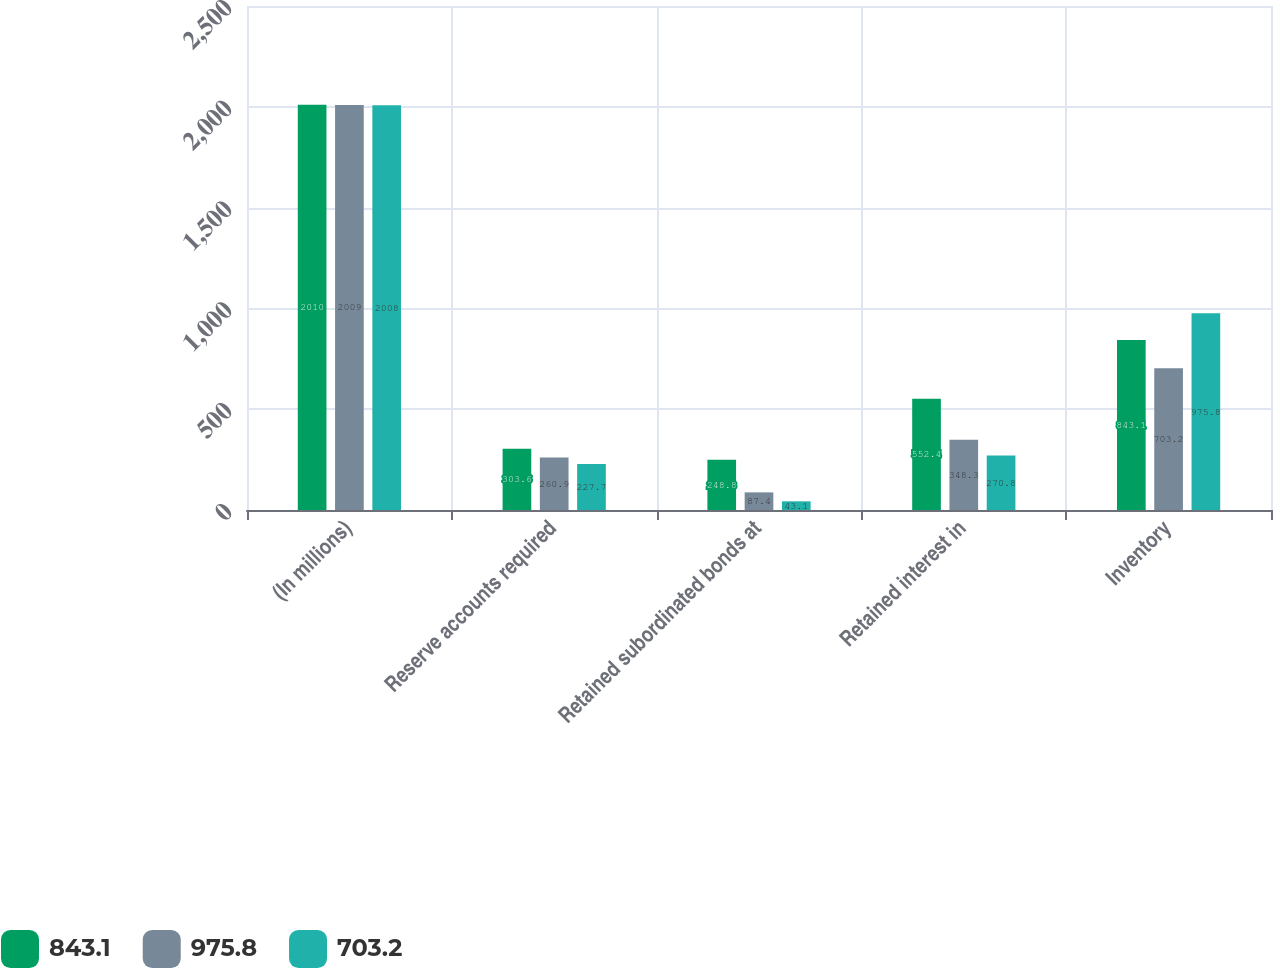Convert chart to OTSL. <chart><loc_0><loc_0><loc_500><loc_500><stacked_bar_chart><ecel><fcel>(In millions)<fcel>Reserve accounts required<fcel>Retained subordinated bonds at<fcel>Retained interest in<fcel>Inventory<nl><fcel>843.1<fcel>2010<fcel>303.6<fcel>248.8<fcel>552.4<fcel>843.1<nl><fcel>975.8<fcel>2009<fcel>260.9<fcel>87.4<fcel>348.3<fcel>703.2<nl><fcel>703.2<fcel>2008<fcel>227.7<fcel>43.1<fcel>270.8<fcel>975.8<nl></chart> 